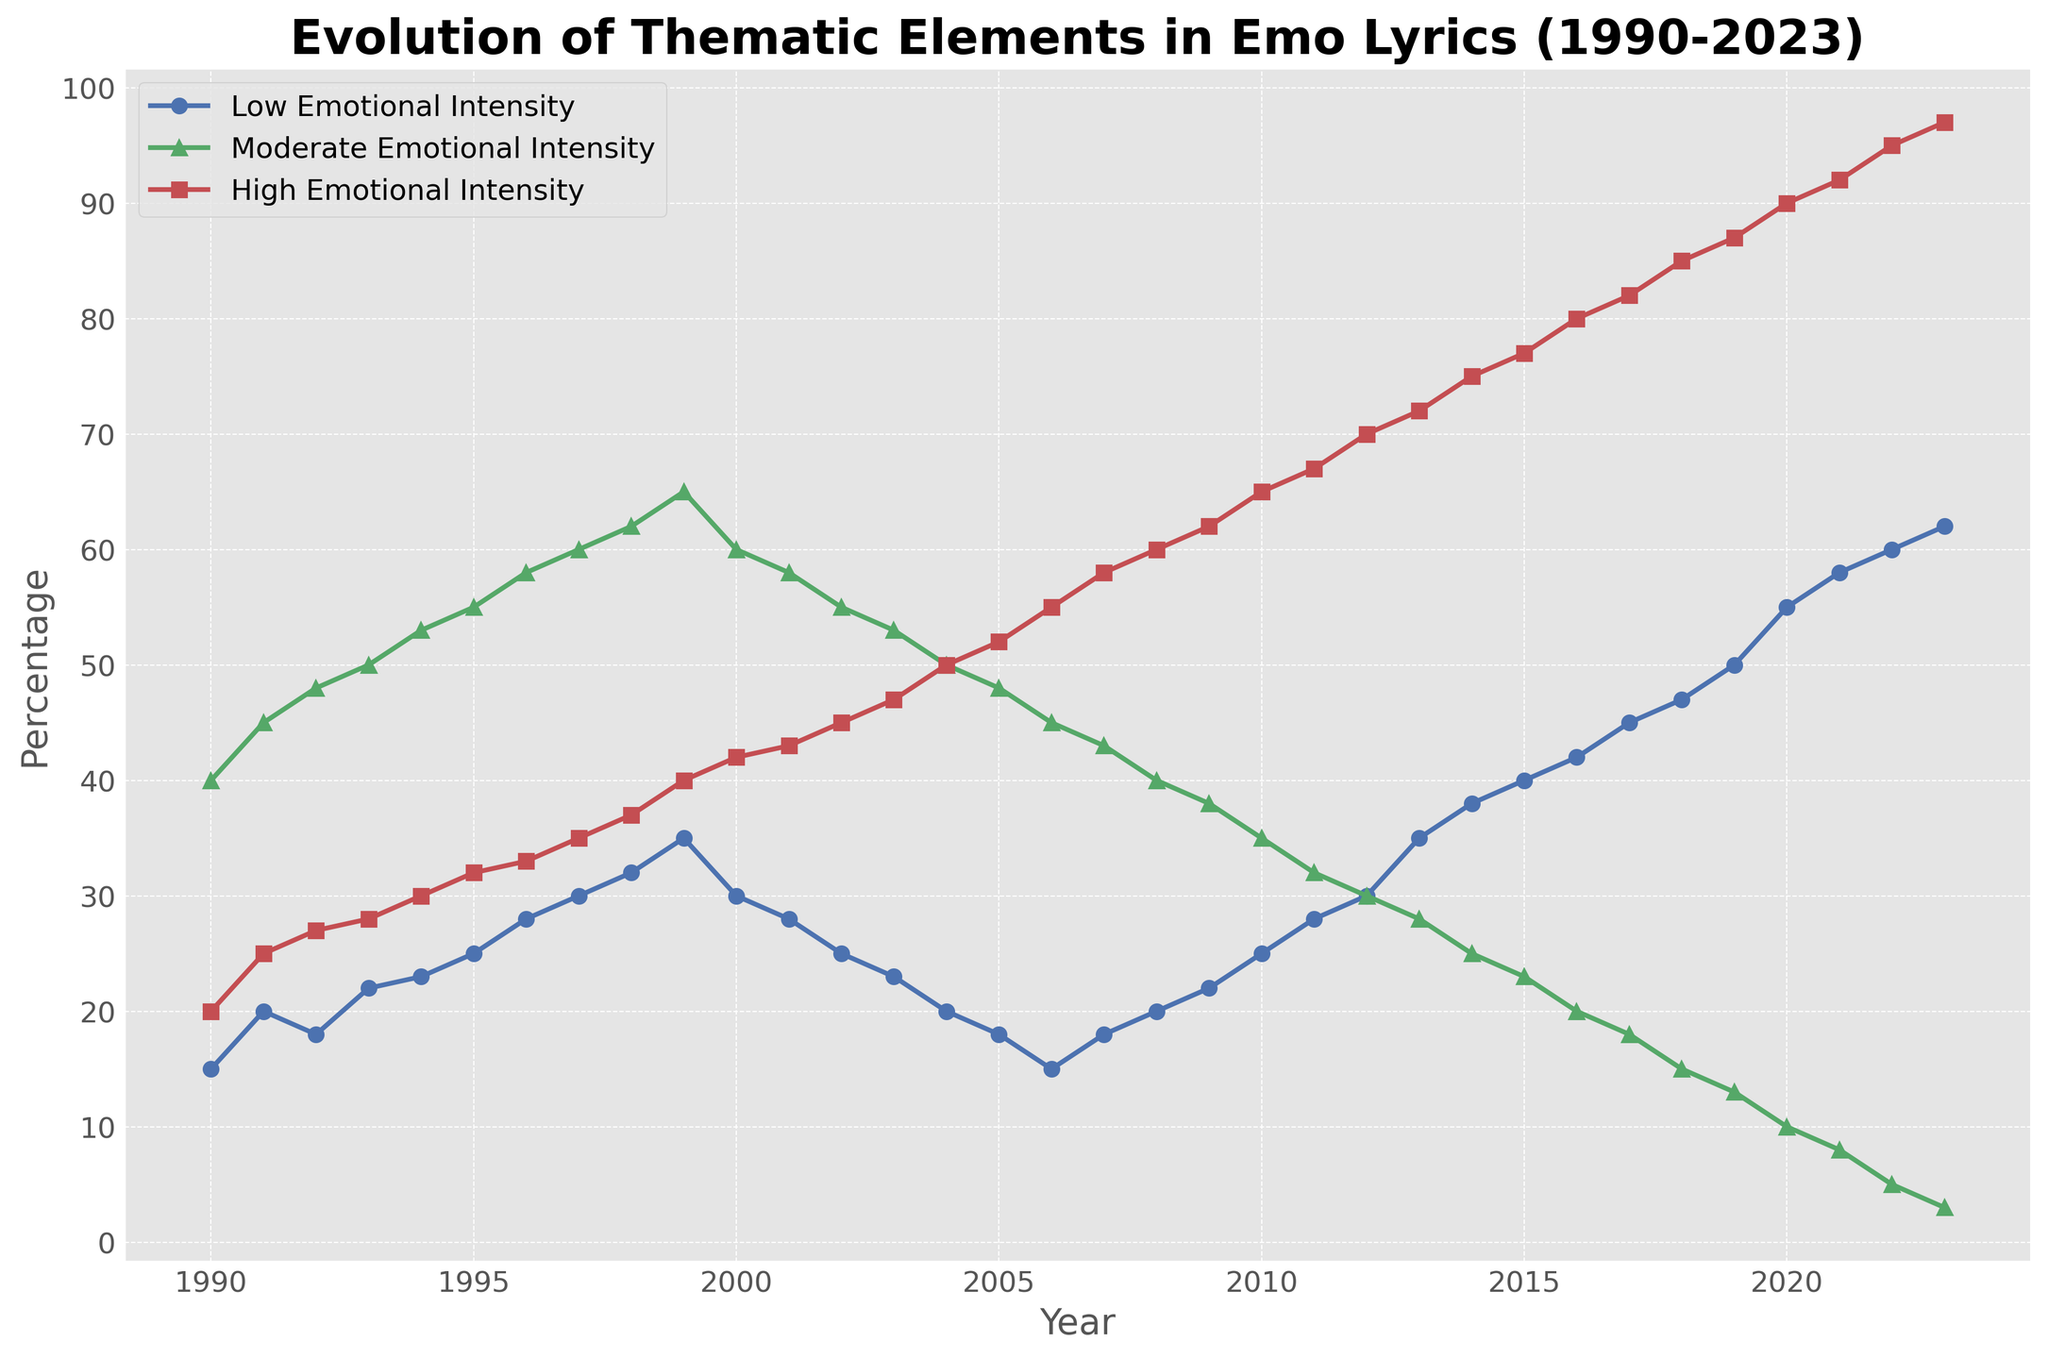What trend can be observed for "High Emotional Intensity" lyrics from 1990 to 2023? The percentage of "High Emotional Intensity" lyrics shows a clear increasing trend over the years. Starting from 20% in 1990, it steadily rises to 97% by 2023.
Answer: Increasing trend Between 2000 and 2010, which year had the highest percentage of "Moderate Emotional Intensity" lyrics? By examining the data points from 2000 to 2010, 2000 had the highest percentage of "Moderate Emotional Intensity" lyrics at 60%.
Answer: 2000 In 2020, what is the difference in percentages between "Low Emotional Intensity" and "High Emotional Intensity" lyrics? In 2020, "Low Emotional Intensity" lyrics are at 55%, and "High Emotional Intensity" lyrics are at 90%. The difference is 90% - 55% = 35%.
Answer: 35% How does the percentage of "Low Emotional Intensity" lyrics change from 1990 to 2008? The percentage of "Low Emotional Intensity" lyrics starts at 15% in 1990, gradually rises until 1999 reaching 35%, then dips to 18% by 2008.
Answer: Gradual rise, then dip In which year does "High Emotional Intensity" surpass 50% for the first time? By checking the data, "High Emotional Intensity" surpasses 50% in 2004, where it reaches exactly 50%.
Answer: 2004 Compare the percentages of "Low Emotional Intensity" and "Moderate Emotional Intensity" in 2023. Which one is greater, and by how much? In 2023, "Low Emotional Intensity" is at 62%, while "Moderate Emotional Intensity" is at 3%. The difference is 62% - 3% = 59%, with "Low Emotional Intensity" being greater.
Answer: "Low Emotional Intensity" by 59% What is the average percentage of "High Emotional Intensity" lyrics from 2000 to 2010? Summing the percentages from 2000 to 2010: (42 + 43 + 45 + 47 + 50 + 52 + 55 + 58 + 60 + 62 + 65) = 529. The average is 529 / 11 ≈ 48.09%.
Answer: Approximately 48.09% How do the percentages of "Moderate Emotional Intensity" change from 1997 to 2007? "Moderate Emotional Intensity" begins at 60% in 1997 and decreases consistently to 43% by 2007.
Answer: Steadily decreases 